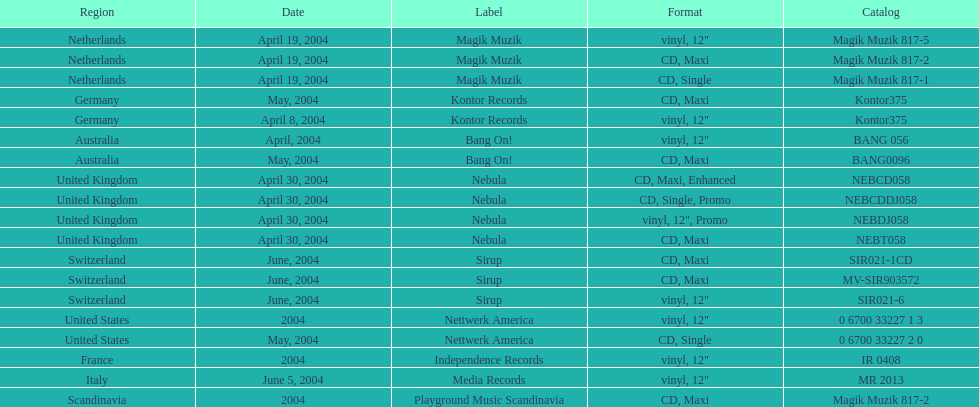What categorization did italy have? Media Records. 